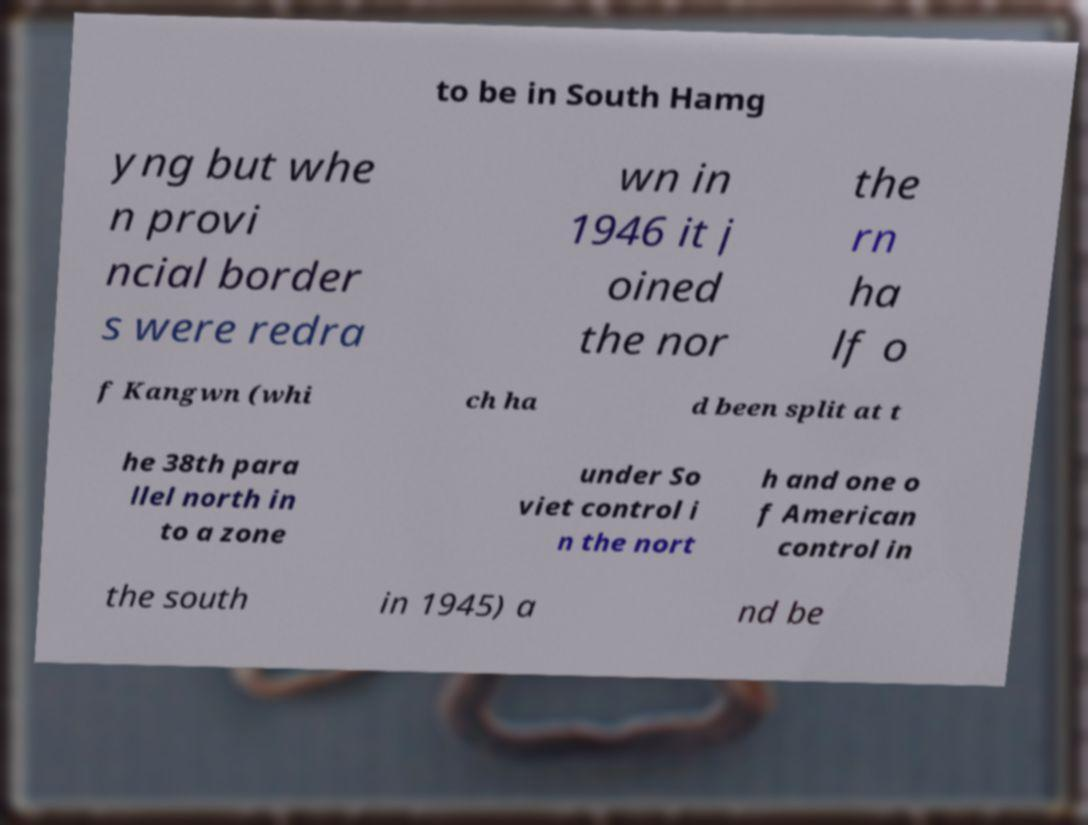For documentation purposes, I need the text within this image transcribed. Could you provide that? to be in South Hamg yng but whe n provi ncial border s were redra wn in 1946 it j oined the nor the rn ha lf o f Kangwn (whi ch ha d been split at t he 38th para llel north in to a zone under So viet control i n the nort h and one o f American control in the south in 1945) a nd be 